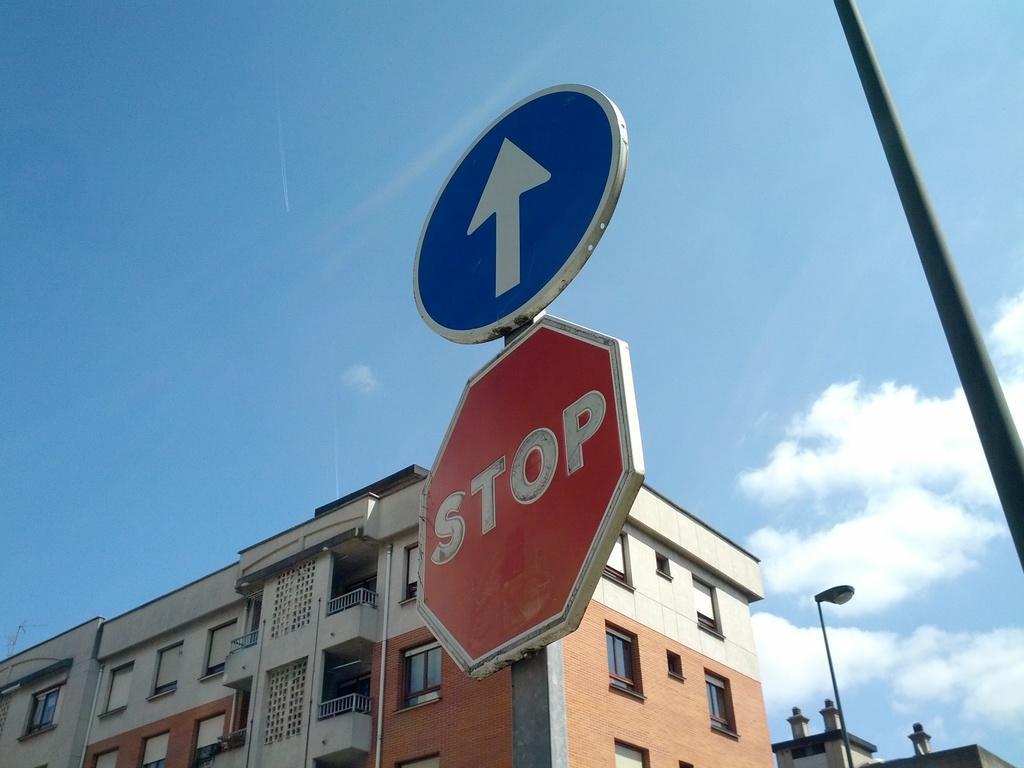Can you describe this image briefly? In the picture we can see a building with windows and glasses to it and near to the building we can see a pole with stop board and on top of it we can see a arrow which is upward on the board and beside the board we can see another pole and beside the building we can see a pole with light and behind and some building constructions and sky with clouds. 